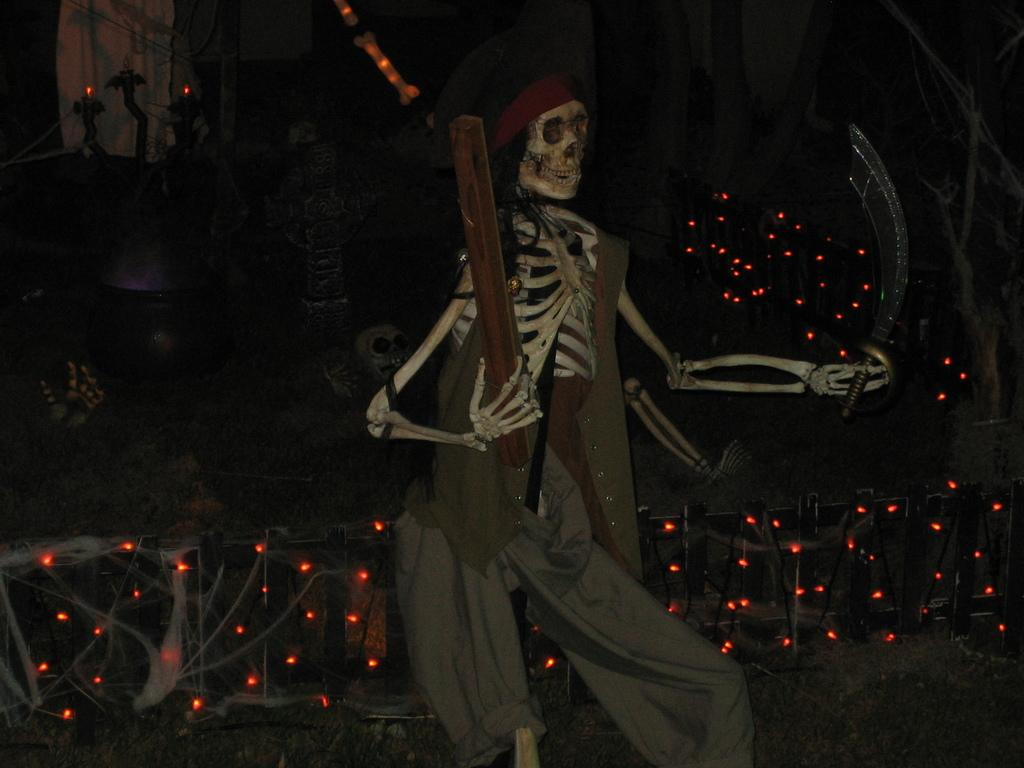What is the main subject of the image? There is a skeleton in the image. What is the skeleton wearing? The skeleton is wearing a dress. What can be seen at the bottom of the image? There are lights and trees at the bottom of the image. What is located on the left side of the image? There is a building on the left side of the image. How much throat lozenges does the skeleton have in the image? There is no mention of throat lozenges in the image, so it is impossible to determine the amount. 